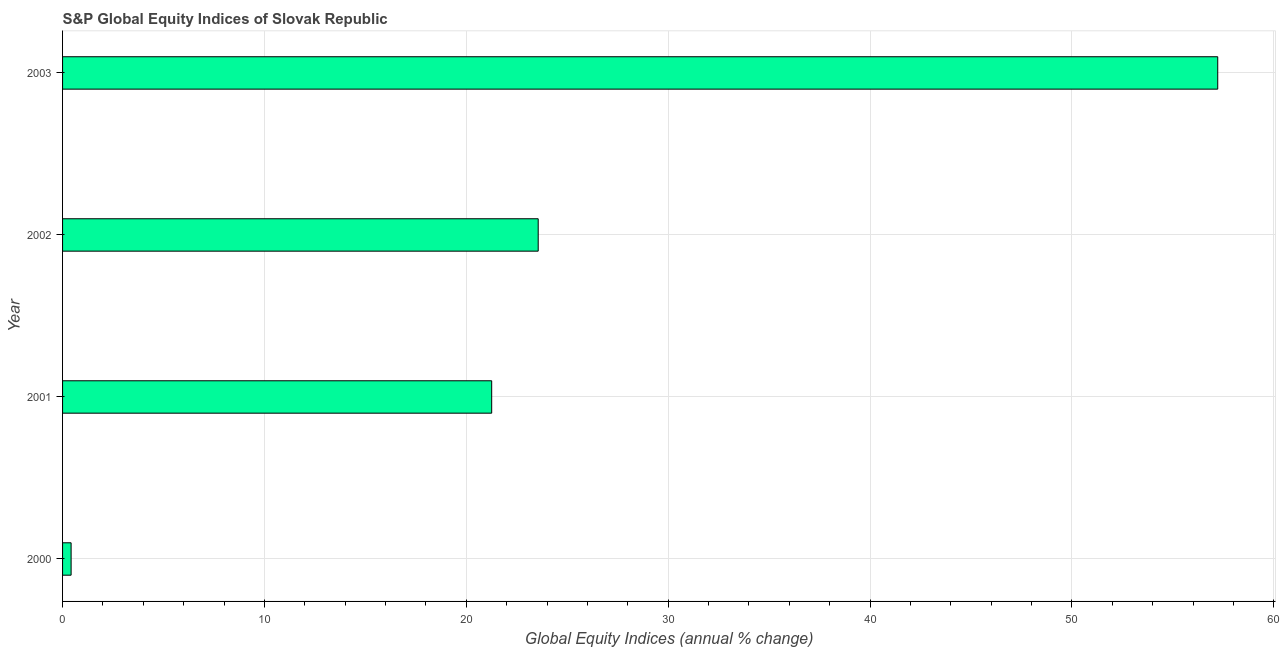Does the graph contain any zero values?
Provide a short and direct response. No. What is the title of the graph?
Give a very brief answer. S&P Global Equity Indices of Slovak Republic. What is the label or title of the X-axis?
Your answer should be compact. Global Equity Indices (annual % change). What is the s&p global equity indices in 2001?
Give a very brief answer. 21.26. Across all years, what is the maximum s&p global equity indices?
Offer a terse response. 57.22. Across all years, what is the minimum s&p global equity indices?
Ensure brevity in your answer.  0.42. In which year was the s&p global equity indices maximum?
Offer a very short reply. 2003. In which year was the s&p global equity indices minimum?
Make the answer very short. 2000. What is the sum of the s&p global equity indices?
Keep it short and to the point. 102.46. What is the difference between the s&p global equity indices in 2000 and 2001?
Make the answer very short. -20.83. What is the average s&p global equity indices per year?
Make the answer very short. 25.61. What is the median s&p global equity indices?
Give a very brief answer. 22.41. Do a majority of the years between 2002 and 2003 (inclusive) have s&p global equity indices greater than 2 %?
Offer a very short reply. Yes. What is the ratio of the s&p global equity indices in 2001 to that in 2002?
Give a very brief answer. 0.9. Is the difference between the s&p global equity indices in 2002 and 2003 greater than the difference between any two years?
Provide a succinct answer. No. What is the difference between the highest and the second highest s&p global equity indices?
Give a very brief answer. 33.66. What is the difference between the highest and the lowest s&p global equity indices?
Provide a succinct answer. 56.8. In how many years, is the s&p global equity indices greater than the average s&p global equity indices taken over all years?
Your answer should be very brief. 1. How many bars are there?
Provide a succinct answer. 4. How many years are there in the graph?
Your response must be concise. 4. What is the difference between two consecutive major ticks on the X-axis?
Make the answer very short. 10. Are the values on the major ticks of X-axis written in scientific E-notation?
Offer a terse response. No. What is the Global Equity Indices (annual % change) in 2000?
Provide a short and direct response. 0.42. What is the Global Equity Indices (annual % change) of 2001?
Your answer should be compact. 21.26. What is the Global Equity Indices (annual % change) of 2002?
Keep it short and to the point. 23.56. What is the Global Equity Indices (annual % change) in 2003?
Make the answer very short. 57.22. What is the difference between the Global Equity Indices (annual % change) in 2000 and 2001?
Your answer should be compact. -20.83. What is the difference between the Global Equity Indices (annual % change) in 2000 and 2002?
Provide a succinct answer. -23.14. What is the difference between the Global Equity Indices (annual % change) in 2000 and 2003?
Your answer should be very brief. -56.8. What is the difference between the Global Equity Indices (annual % change) in 2001 and 2002?
Your answer should be very brief. -2.3. What is the difference between the Global Equity Indices (annual % change) in 2001 and 2003?
Your answer should be compact. -35.96. What is the difference between the Global Equity Indices (annual % change) in 2002 and 2003?
Provide a succinct answer. -33.66. What is the ratio of the Global Equity Indices (annual % change) in 2000 to that in 2001?
Your response must be concise. 0.02. What is the ratio of the Global Equity Indices (annual % change) in 2000 to that in 2002?
Provide a succinct answer. 0.02. What is the ratio of the Global Equity Indices (annual % change) in 2000 to that in 2003?
Make the answer very short. 0.01. What is the ratio of the Global Equity Indices (annual % change) in 2001 to that in 2002?
Make the answer very short. 0.9. What is the ratio of the Global Equity Indices (annual % change) in 2001 to that in 2003?
Your answer should be compact. 0.37. What is the ratio of the Global Equity Indices (annual % change) in 2002 to that in 2003?
Provide a short and direct response. 0.41. 